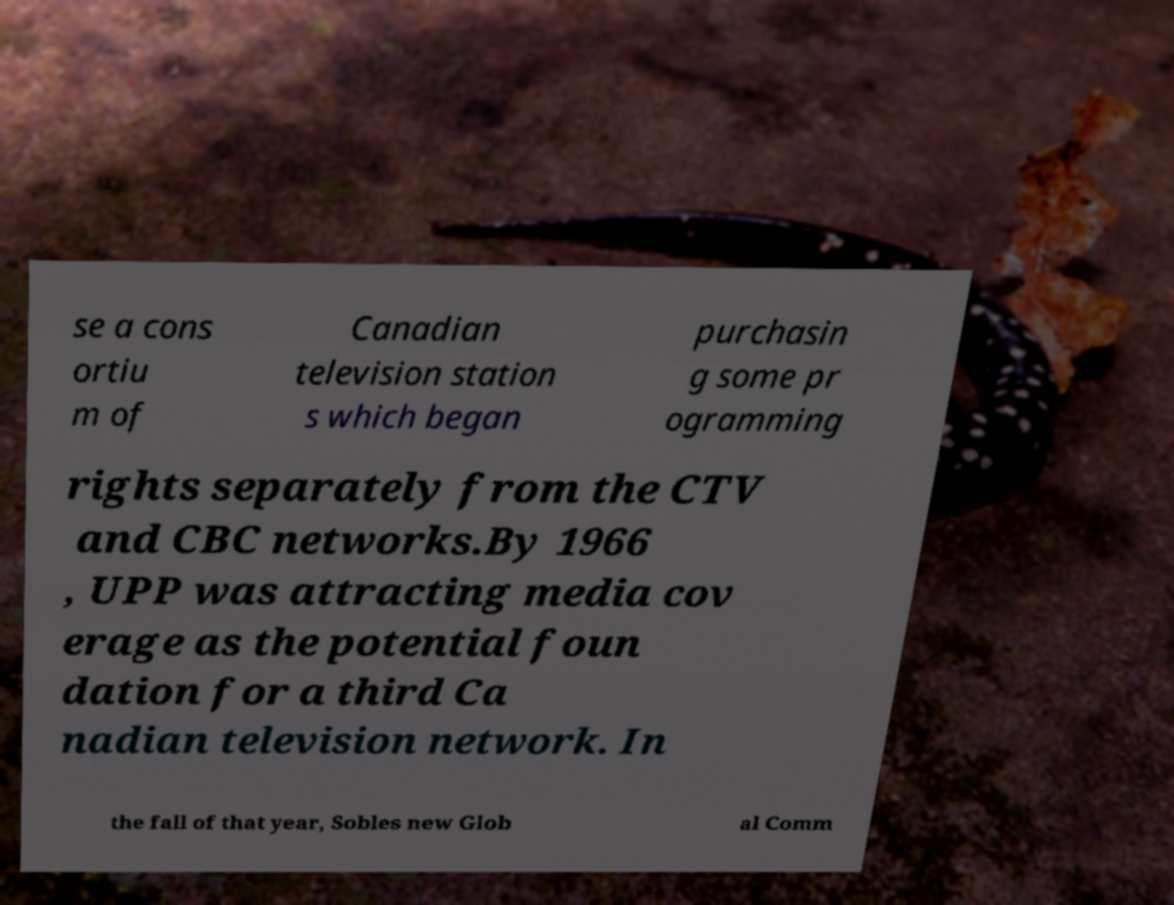Please read and relay the text visible in this image. What does it say? se a cons ortiu m of Canadian television station s which began purchasin g some pr ogramming rights separately from the CTV and CBC networks.By 1966 , UPP was attracting media cov erage as the potential foun dation for a third Ca nadian television network. In the fall of that year, Sobles new Glob al Comm 